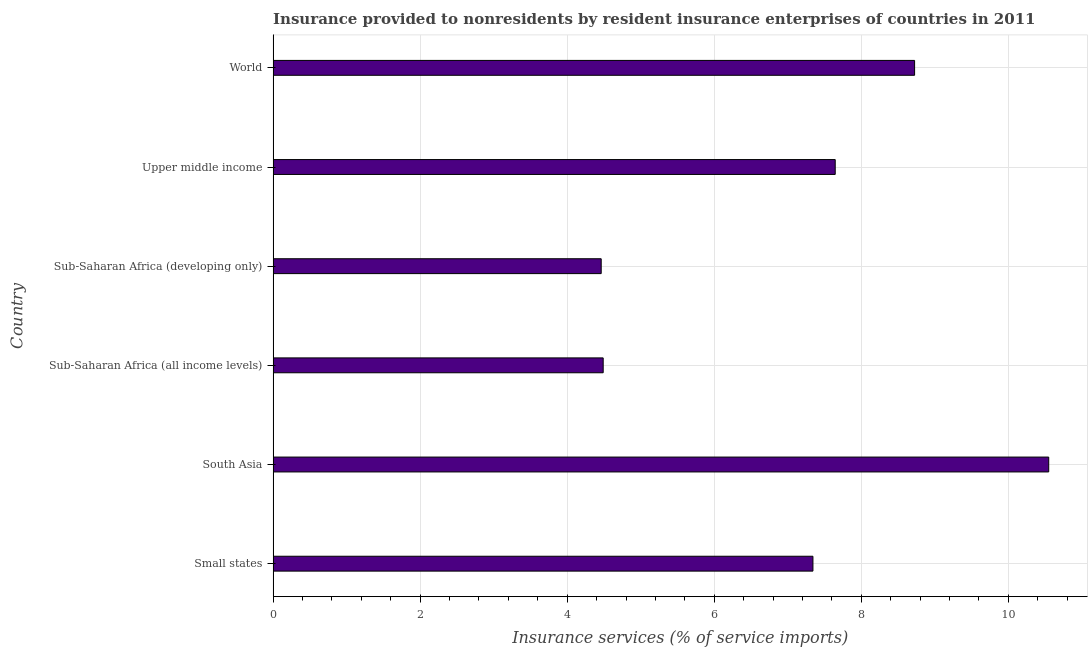Does the graph contain grids?
Offer a very short reply. Yes. What is the title of the graph?
Your response must be concise. Insurance provided to nonresidents by resident insurance enterprises of countries in 2011. What is the label or title of the X-axis?
Offer a terse response. Insurance services (% of service imports). What is the label or title of the Y-axis?
Ensure brevity in your answer.  Country. What is the insurance and financial services in Small states?
Provide a short and direct response. 7.34. Across all countries, what is the maximum insurance and financial services?
Your response must be concise. 10.55. Across all countries, what is the minimum insurance and financial services?
Offer a terse response. 4.46. In which country was the insurance and financial services maximum?
Your answer should be compact. South Asia. In which country was the insurance and financial services minimum?
Your response must be concise. Sub-Saharan Africa (developing only). What is the sum of the insurance and financial services?
Your answer should be compact. 43.22. What is the difference between the insurance and financial services in Small states and World?
Your response must be concise. -1.38. What is the average insurance and financial services per country?
Provide a short and direct response. 7.2. What is the median insurance and financial services?
Offer a terse response. 7.49. In how many countries, is the insurance and financial services greater than 8.4 %?
Your answer should be compact. 2. What is the ratio of the insurance and financial services in Upper middle income to that in World?
Your answer should be compact. 0.88. What is the difference between the highest and the second highest insurance and financial services?
Your answer should be compact. 1.82. What is the difference between the highest and the lowest insurance and financial services?
Your answer should be compact. 6.09. In how many countries, is the insurance and financial services greater than the average insurance and financial services taken over all countries?
Ensure brevity in your answer.  4. Are all the bars in the graph horizontal?
Your response must be concise. Yes. How many countries are there in the graph?
Provide a short and direct response. 6. Are the values on the major ticks of X-axis written in scientific E-notation?
Your answer should be very brief. No. What is the Insurance services (% of service imports) of Small states?
Offer a terse response. 7.34. What is the Insurance services (% of service imports) in South Asia?
Your answer should be compact. 10.55. What is the Insurance services (% of service imports) in Sub-Saharan Africa (all income levels)?
Offer a very short reply. 4.49. What is the Insurance services (% of service imports) of Sub-Saharan Africa (developing only)?
Offer a very short reply. 4.46. What is the Insurance services (% of service imports) of Upper middle income?
Make the answer very short. 7.65. What is the Insurance services (% of service imports) in World?
Your answer should be compact. 8.73. What is the difference between the Insurance services (% of service imports) in Small states and South Asia?
Provide a succinct answer. -3.21. What is the difference between the Insurance services (% of service imports) in Small states and Sub-Saharan Africa (all income levels)?
Make the answer very short. 2.85. What is the difference between the Insurance services (% of service imports) in Small states and Sub-Saharan Africa (developing only)?
Make the answer very short. 2.88. What is the difference between the Insurance services (% of service imports) in Small states and Upper middle income?
Keep it short and to the point. -0.3. What is the difference between the Insurance services (% of service imports) in Small states and World?
Your response must be concise. -1.38. What is the difference between the Insurance services (% of service imports) in South Asia and Sub-Saharan Africa (all income levels)?
Ensure brevity in your answer.  6.06. What is the difference between the Insurance services (% of service imports) in South Asia and Sub-Saharan Africa (developing only)?
Provide a short and direct response. 6.09. What is the difference between the Insurance services (% of service imports) in South Asia and Upper middle income?
Offer a very short reply. 2.9. What is the difference between the Insurance services (% of service imports) in South Asia and World?
Offer a terse response. 1.82. What is the difference between the Insurance services (% of service imports) in Sub-Saharan Africa (all income levels) and Sub-Saharan Africa (developing only)?
Give a very brief answer. 0.03. What is the difference between the Insurance services (% of service imports) in Sub-Saharan Africa (all income levels) and Upper middle income?
Your response must be concise. -3.16. What is the difference between the Insurance services (% of service imports) in Sub-Saharan Africa (all income levels) and World?
Give a very brief answer. -4.24. What is the difference between the Insurance services (% of service imports) in Sub-Saharan Africa (developing only) and Upper middle income?
Give a very brief answer. -3.18. What is the difference between the Insurance services (% of service imports) in Sub-Saharan Africa (developing only) and World?
Offer a terse response. -4.26. What is the difference between the Insurance services (% of service imports) in Upper middle income and World?
Your response must be concise. -1.08. What is the ratio of the Insurance services (% of service imports) in Small states to that in South Asia?
Offer a very short reply. 0.7. What is the ratio of the Insurance services (% of service imports) in Small states to that in Sub-Saharan Africa (all income levels)?
Your response must be concise. 1.64. What is the ratio of the Insurance services (% of service imports) in Small states to that in Sub-Saharan Africa (developing only)?
Provide a succinct answer. 1.65. What is the ratio of the Insurance services (% of service imports) in Small states to that in Upper middle income?
Offer a terse response. 0.96. What is the ratio of the Insurance services (% of service imports) in Small states to that in World?
Offer a terse response. 0.84. What is the ratio of the Insurance services (% of service imports) in South Asia to that in Sub-Saharan Africa (all income levels)?
Ensure brevity in your answer.  2.35. What is the ratio of the Insurance services (% of service imports) in South Asia to that in Sub-Saharan Africa (developing only)?
Keep it short and to the point. 2.36. What is the ratio of the Insurance services (% of service imports) in South Asia to that in Upper middle income?
Provide a short and direct response. 1.38. What is the ratio of the Insurance services (% of service imports) in South Asia to that in World?
Make the answer very short. 1.21. What is the ratio of the Insurance services (% of service imports) in Sub-Saharan Africa (all income levels) to that in Sub-Saharan Africa (developing only)?
Your response must be concise. 1.01. What is the ratio of the Insurance services (% of service imports) in Sub-Saharan Africa (all income levels) to that in Upper middle income?
Your answer should be compact. 0.59. What is the ratio of the Insurance services (% of service imports) in Sub-Saharan Africa (all income levels) to that in World?
Your answer should be compact. 0.52. What is the ratio of the Insurance services (% of service imports) in Sub-Saharan Africa (developing only) to that in Upper middle income?
Provide a short and direct response. 0.58. What is the ratio of the Insurance services (% of service imports) in Sub-Saharan Africa (developing only) to that in World?
Make the answer very short. 0.51. What is the ratio of the Insurance services (% of service imports) in Upper middle income to that in World?
Keep it short and to the point. 0.88. 